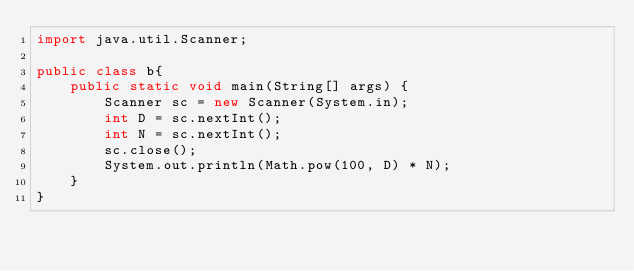Convert code to text. <code><loc_0><loc_0><loc_500><loc_500><_Java_>import java.util.Scanner;

public class b{
    public static void main(String[] args) {
        Scanner sc = new Scanner(System.in);
        int D = sc.nextInt();
        int N = sc.nextInt();
        sc.close();
        System.out.println(Math.pow(100, D) * N);
    }
}</code> 